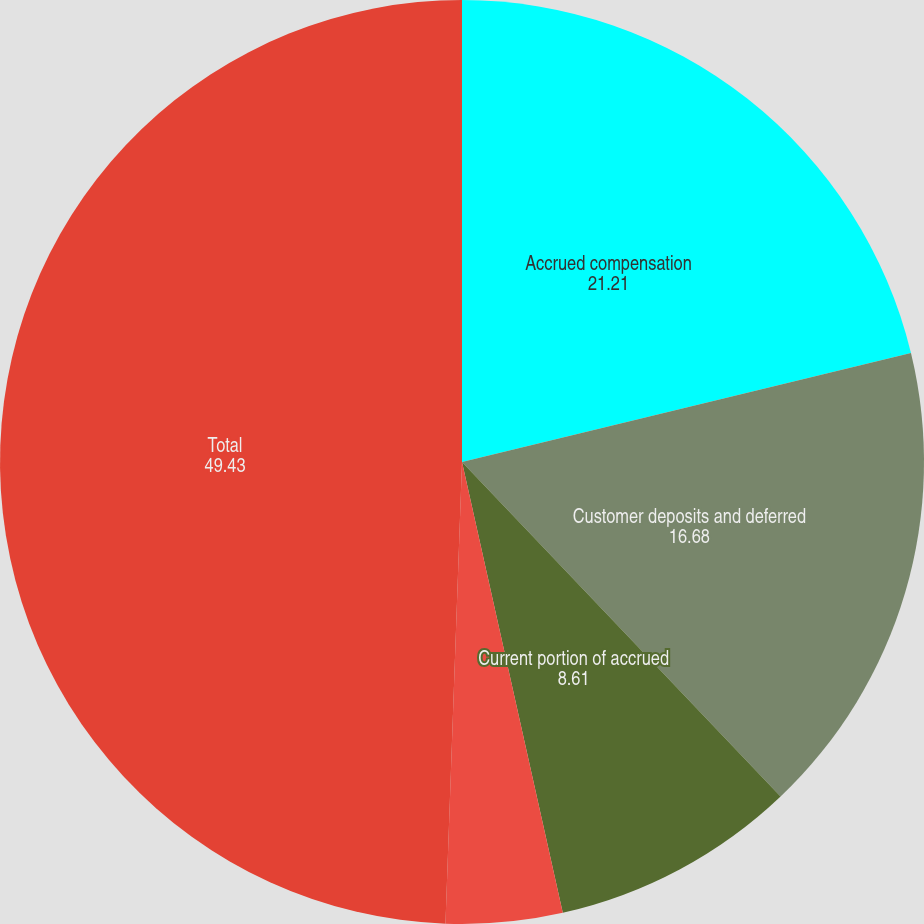<chart> <loc_0><loc_0><loc_500><loc_500><pie_chart><fcel>Accrued compensation<fcel>Customer deposits and deferred<fcel>Current portion of accrued<fcel>Other<fcel>Total<nl><fcel>21.21%<fcel>16.68%<fcel>8.61%<fcel>4.07%<fcel>49.43%<nl></chart> 